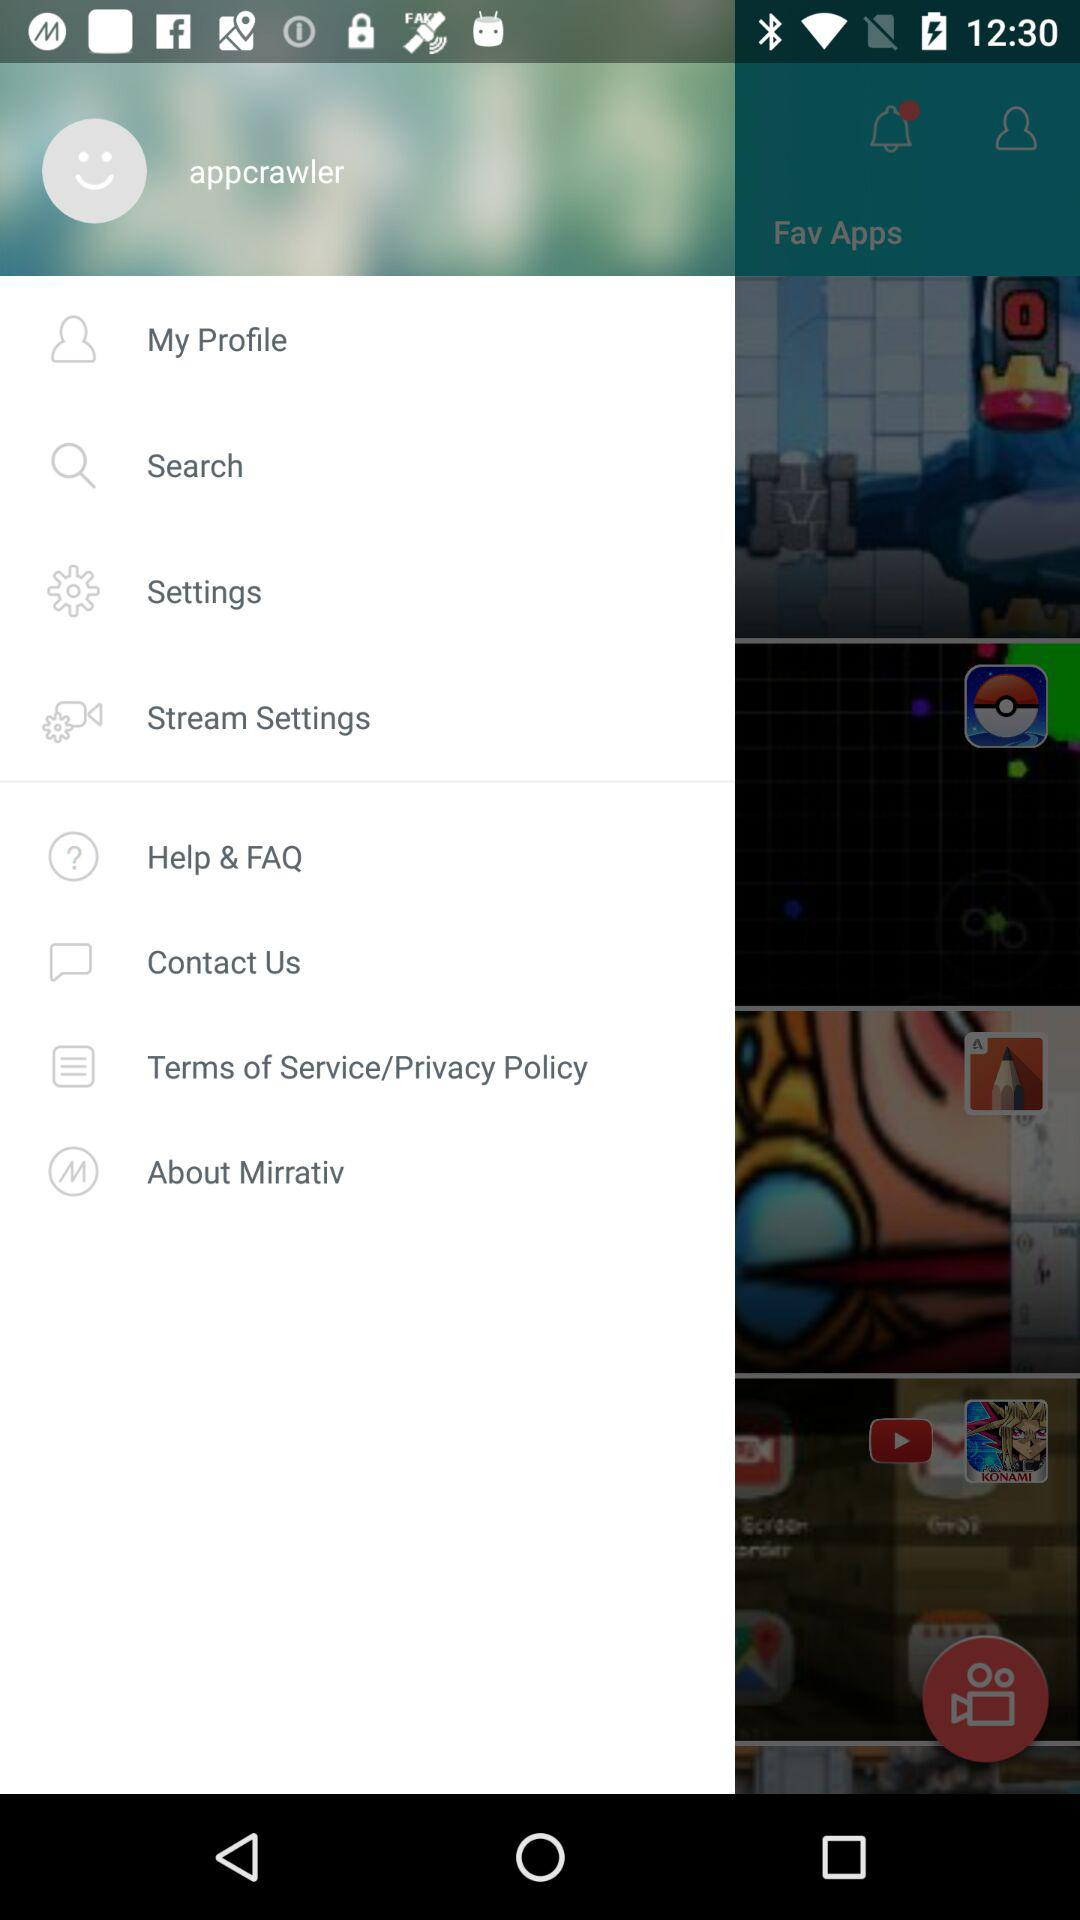How many notifications are there in "Settings"?
When the provided information is insufficient, respond with <no answer>. <no answer> 